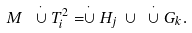<formula> <loc_0><loc_0><loc_500><loc_500>M \ \stackrel { \cdot } \cup T _ { i } ^ { 2 } = \stackrel { \cdot } \cup H _ { j } \ \cup \ \stackrel { \cdot } \cup G _ { k } .</formula> 